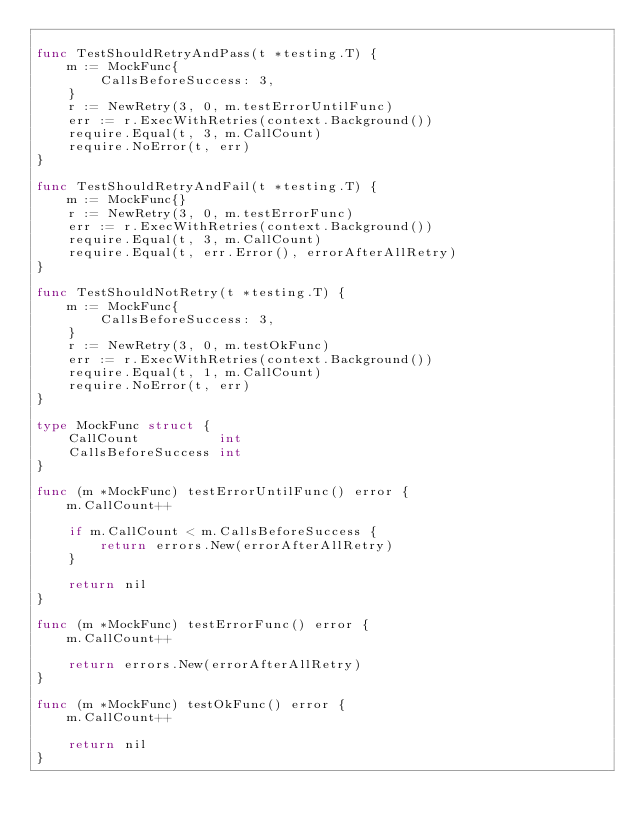Convert code to text. <code><loc_0><loc_0><loc_500><loc_500><_Go_>
func TestShouldRetryAndPass(t *testing.T) {
	m := MockFunc{
		CallsBeforeSuccess: 3,
	}
	r := NewRetry(3, 0, m.testErrorUntilFunc)
	err := r.ExecWithRetries(context.Background())
	require.Equal(t, 3, m.CallCount)
	require.NoError(t, err)
}

func TestShouldRetryAndFail(t *testing.T) {
	m := MockFunc{}
	r := NewRetry(3, 0, m.testErrorFunc)
	err := r.ExecWithRetries(context.Background())
	require.Equal(t, 3, m.CallCount)
	require.Equal(t, err.Error(), errorAfterAllRetry)
}

func TestShouldNotRetry(t *testing.T) {
	m := MockFunc{
		CallsBeforeSuccess: 3,
	}
	r := NewRetry(3, 0, m.testOkFunc)
	err := r.ExecWithRetries(context.Background())
	require.Equal(t, 1, m.CallCount)
	require.NoError(t, err)
}

type MockFunc struct {
	CallCount          int
	CallsBeforeSuccess int
}

func (m *MockFunc) testErrorUntilFunc() error {
	m.CallCount++

	if m.CallCount < m.CallsBeforeSuccess {
		return errors.New(errorAfterAllRetry)
	}

	return nil
}

func (m *MockFunc) testErrorFunc() error {
	m.CallCount++

	return errors.New(errorAfterAllRetry)
}

func (m *MockFunc) testOkFunc() error {
	m.CallCount++

	return nil
}
</code> 